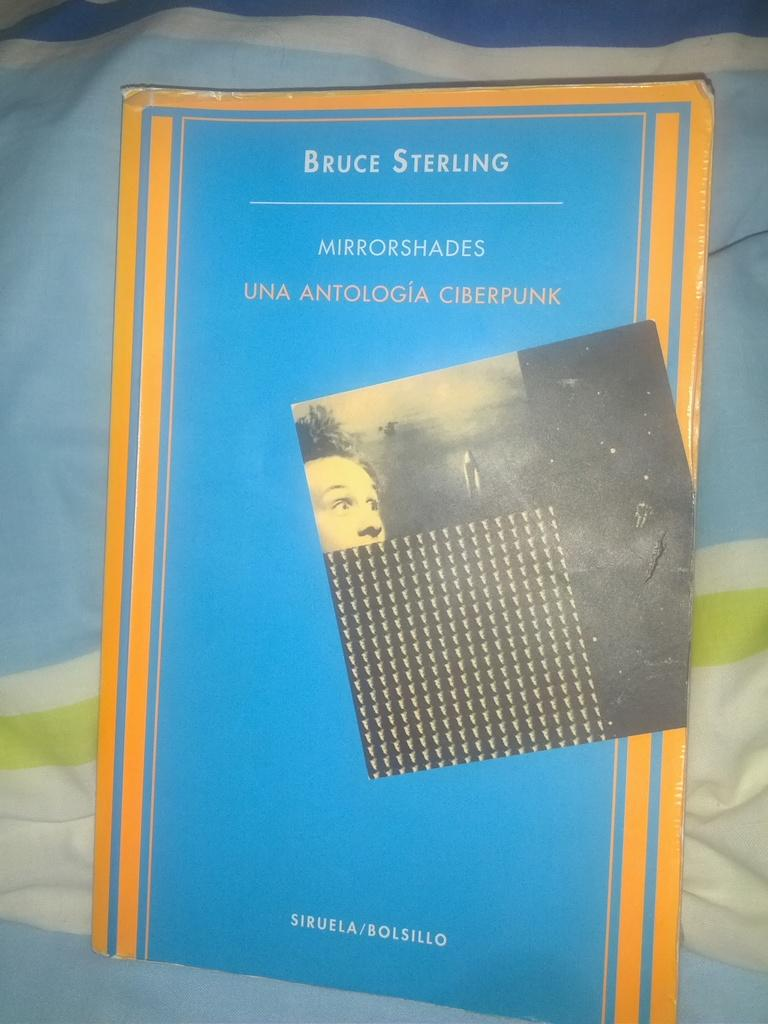<image>
Describe the image concisely. The book is written by the author Bruce Sterling 